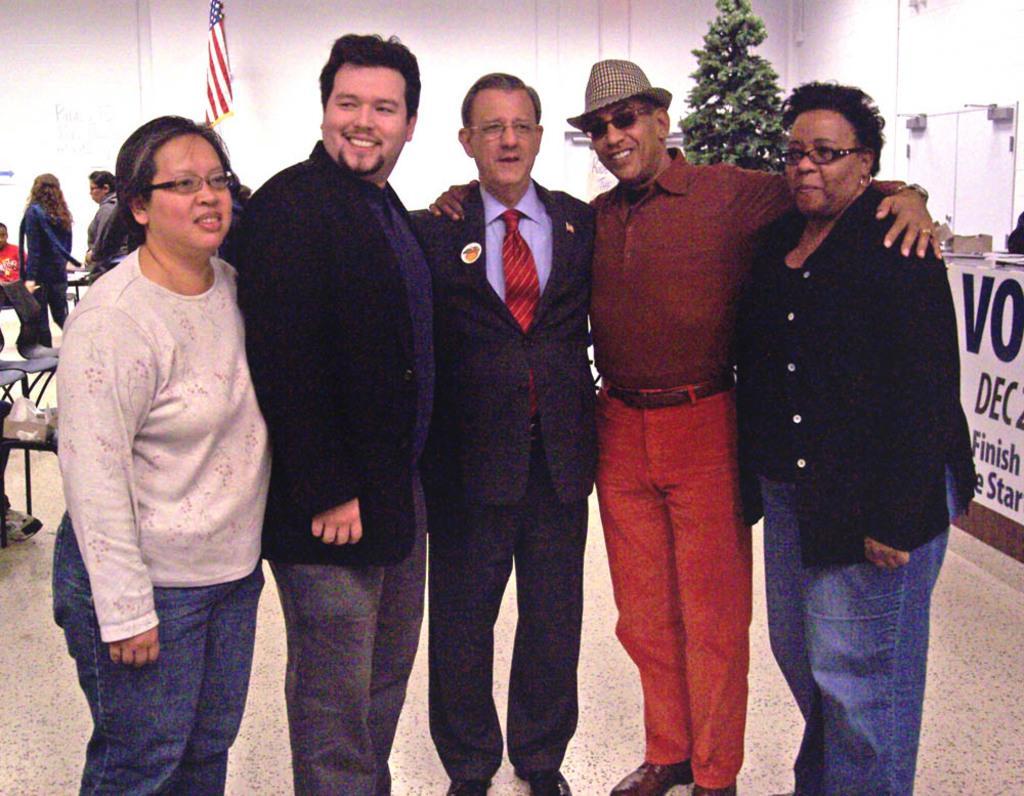How would you summarize this image in a sentence or two? In the center of the image there are people standing. In the background of the image there is wall. There is a flag. There are people. There is plant. At the bottom of the image there is floor. 